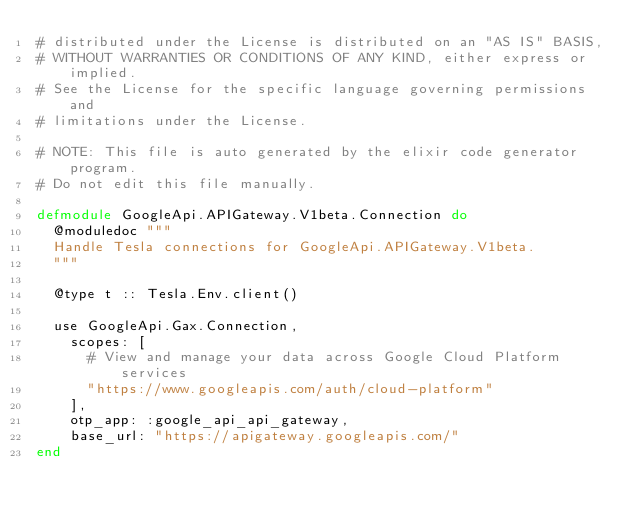<code> <loc_0><loc_0><loc_500><loc_500><_Elixir_># distributed under the License is distributed on an "AS IS" BASIS,
# WITHOUT WARRANTIES OR CONDITIONS OF ANY KIND, either express or implied.
# See the License for the specific language governing permissions and
# limitations under the License.

# NOTE: This file is auto generated by the elixir code generator program.
# Do not edit this file manually.

defmodule GoogleApi.APIGateway.V1beta.Connection do
  @moduledoc """
  Handle Tesla connections for GoogleApi.APIGateway.V1beta.
  """

  @type t :: Tesla.Env.client()

  use GoogleApi.Gax.Connection,
    scopes: [
      # View and manage your data across Google Cloud Platform services
      "https://www.googleapis.com/auth/cloud-platform"
    ],
    otp_app: :google_api_api_gateway,
    base_url: "https://apigateway.googleapis.com/"
end
</code> 